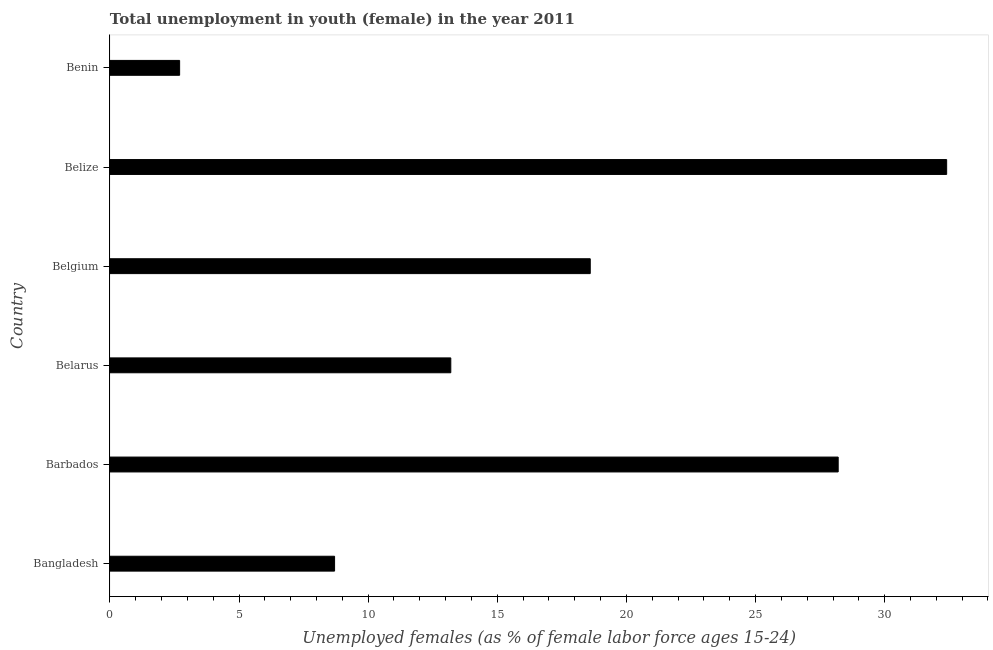Does the graph contain any zero values?
Provide a short and direct response. No. Does the graph contain grids?
Your response must be concise. No. What is the title of the graph?
Provide a short and direct response. Total unemployment in youth (female) in the year 2011. What is the label or title of the X-axis?
Provide a succinct answer. Unemployed females (as % of female labor force ages 15-24). What is the unemployed female youth population in Belgium?
Provide a short and direct response. 18.6. Across all countries, what is the maximum unemployed female youth population?
Your answer should be very brief. 32.4. Across all countries, what is the minimum unemployed female youth population?
Give a very brief answer. 2.7. In which country was the unemployed female youth population maximum?
Offer a very short reply. Belize. In which country was the unemployed female youth population minimum?
Ensure brevity in your answer.  Benin. What is the sum of the unemployed female youth population?
Ensure brevity in your answer.  103.8. What is the difference between the unemployed female youth population in Bangladesh and Barbados?
Give a very brief answer. -19.5. What is the average unemployed female youth population per country?
Make the answer very short. 17.3. What is the median unemployed female youth population?
Offer a terse response. 15.9. Is the difference between the unemployed female youth population in Bangladesh and Belize greater than the difference between any two countries?
Make the answer very short. No. What is the difference between the highest and the lowest unemployed female youth population?
Provide a short and direct response. 29.7. In how many countries, is the unemployed female youth population greater than the average unemployed female youth population taken over all countries?
Provide a short and direct response. 3. How many bars are there?
Offer a very short reply. 6. What is the difference between two consecutive major ticks on the X-axis?
Offer a very short reply. 5. What is the Unemployed females (as % of female labor force ages 15-24) of Bangladesh?
Offer a terse response. 8.7. What is the Unemployed females (as % of female labor force ages 15-24) of Barbados?
Provide a succinct answer. 28.2. What is the Unemployed females (as % of female labor force ages 15-24) of Belarus?
Keep it short and to the point. 13.2. What is the Unemployed females (as % of female labor force ages 15-24) in Belgium?
Offer a terse response. 18.6. What is the Unemployed females (as % of female labor force ages 15-24) of Belize?
Give a very brief answer. 32.4. What is the Unemployed females (as % of female labor force ages 15-24) in Benin?
Your answer should be compact. 2.7. What is the difference between the Unemployed females (as % of female labor force ages 15-24) in Bangladesh and Barbados?
Make the answer very short. -19.5. What is the difference between the Unemployed females (as % of female labor force ages 15-24) in Bangladesh and Belize?
Offer a terse response. -23.7. What is the difference between the Unemployed females (as % of female labor force ages 15-24) in Barbados and Belize?
Give a very brief answer. -4.2. What is the difference between the Unemployed females (as % of female labor force ages 15-24) in Barbados and Benin?
Keep it short and to the point. 25.5. What is the difference between the Unemployed females (as % of female labor force ages 15-24) in Belarus and Belize?
Your response must be concise. -19.2. What is the difference between the Unemployed females (as % of female labor force ages 15-24) in Belize and Benin?
Ensure brevity in your answer.  29.7. What is the ratio of the Unemployed females (as % of female labor force ages 15-24) in Bangladesh to that in Barbados?
Your answer should be compact. 0.31. What is the ratio of the Unemployed females (as % of female labor force ages 15-24) in Bangladesh to that in Belarus?
Offer a very short reply. 0.66. What is the ratio of the Unemployed females (as % of female labor force ages 15-24) in Bangladesh to that in Belgium?
Provide a short and direct response. 0.47. What is the ratio of the Unemployed females (as % of female labor force ages 15-24) in Bangladesh to that in Belize?
Make the answer very short. 0.27. What is the ratio of the Unemployed females (as % of female labor force ages 15-24) in Bangladesh to that in Benin?
Offer a very short reply. 3.22. What is the ratio of the Unemployed females (as % of female labor force ages 15-24) in Barbados to that in Belarus?
Make the answer very short. 2.14. What is the ratio of the Unemployed females (as % of female labor force ages 15-24) in Barbados to that in Belgium?
Offer a very short reply. 1.52. What is the ratio of the Unemployed females (as % of female labor force ages 15-24) in Barbados to that in Belize?
Your answer should be compact. 0.87. What is the ratio of the Unemployed females (as % of female labor force ages 15-24) in Barbados to that in Benin?
Make the answer very short. 10.44. What is the ratio of the Unemployed females (as % of female labor force ages 15-24) in Belarus to that in Belgium?
Provide a short and direct response. 0.71. What is the ratio of the Unemployed females (as % of female labor force ages 15-24) in Belarus to that in Belize?
Make the answer very short. 0.41. What is the ratio of the Unemployed females (as % of female labor force ages 15-24) in Belarus to that in Benin?
Your answer should be very brief. 4.89. What is the ratio of the Unemployed females (as % of female labor force ages 15-24) in Belgium to that in Belize?
Offer a terse response. 0.57. What is the ratio of the Unemployed females (as % of female labor force ages 15-24) in Belgium to that in Benin?
Provide a succinct answer. 6.89. What is the ratio of the Unemployed females (as % of female labor force ages 15-24) in Belize to that in Benin?
Ensure brevity in your answer.  12. 